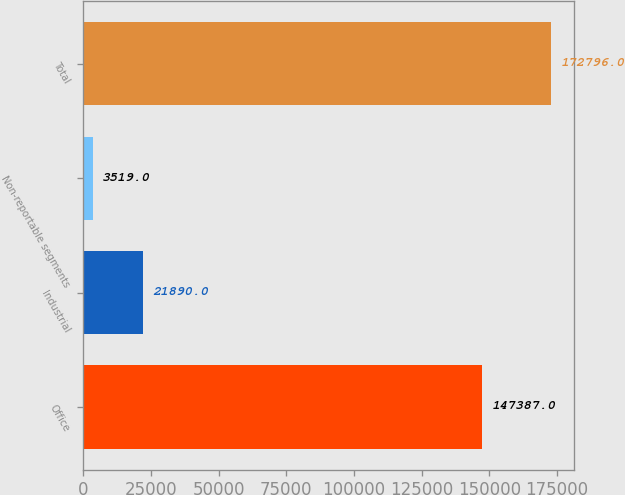Convert chart. <chart><loc_0><loc_0><loc_500><loc_500><bar_chart><fcel>Office<fcel>Industrial<fcel>Non-reportable segments<fcel>Total<nl><fcel>147387<fcel>21890<fcel>3519<fcel>172796<nl></chart> 